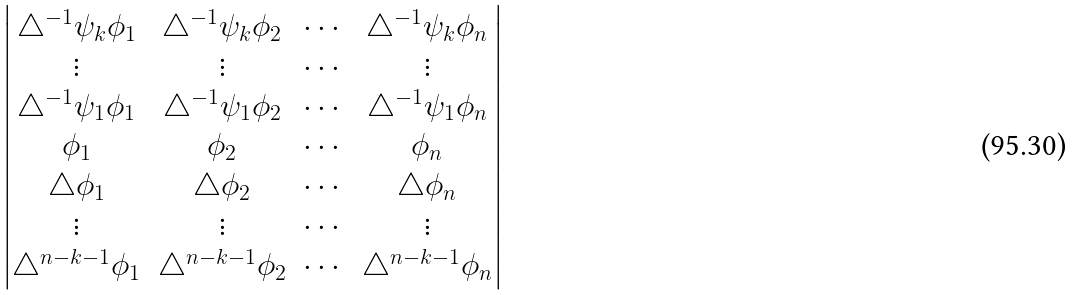<formula> <loc_0><loc_0><loc_500><loc_500>\begin{vmatrix} \triangle ^ { - 1 } \psi _ { k } \phi _ { 1 } & \triangle ^ { - 1 } \psi _ { k } \phi _ { 2 } & \cdots & \triangle ^ { - 1 } \psi _ { k } \phi _ { n } \\ \vdots & \vdots & \cdots & \vdots \\ \triangle ^ { - 1 } \psi _ { 1 } \phi _ { 1 } & \triangle ^ { - 1 } \psi _ { 1 } \phi _ { 2 } & \cdots & \triangle ^ { - 1 } \psi _ { 1 } \phi _ { n } \\ \phi _ { 1 } & \phi _ { 2 } & \cdots & \phi _ { n } \\ \triangle \phi _ { 1 } & \triangle \phi _ { 2 } & \cdots & \triangle \phi _ { n } \\ \vdots & \vdots & \cdots & \vdots \\ \triangle ^ { n - k - 1 } \phi _ { 1 } & \triangle ^ { n - k - 1 } \phi _ { 2 } & \cdots & \triangle ^ { n - k - 1 } \phi _ { n } \end{vmatrix}</formula> 